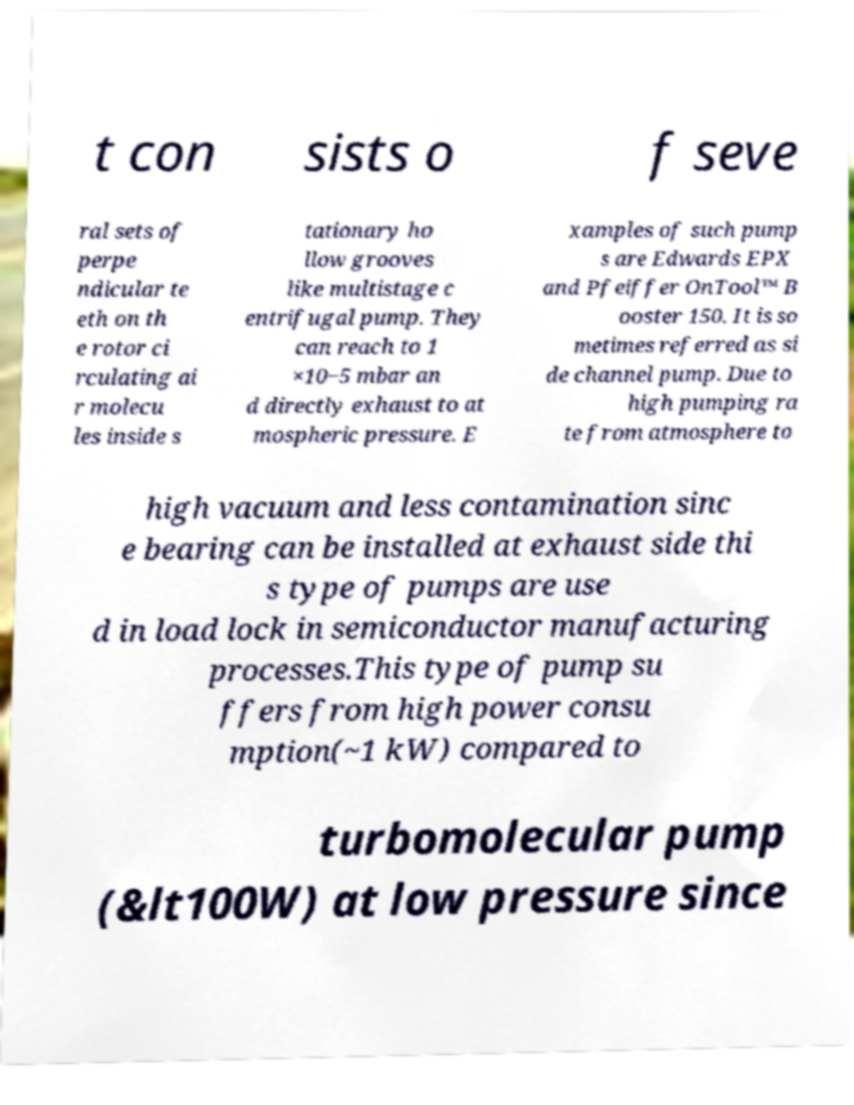I need the written content from this picture converted into text. Can you do that? t con sists o f seve ral sets of perpe ndicular te eth on th e rotor ci rculating ai r molecu les inside s tationary ho llow grooves like multistage c entrifugal pump. They can reach to 1 ×10−5 mbar an d directly exhaust to at mospheric pressure. E xamples of such pump s are Edwards EPX and Pfeiffer OnTool™ B ooster 150. It is so metimes referred as si de channel pump. Due to high pumping ra te from atmosphere to high vacuum and less contamination sinc e bearing can be installed at exhaust side thi s type of pumps are use d in load lock in semiconductor manufacturing processes.This type of pump su ffers from high power consu mption(~1 kW) compared to turbomolecular pump (&lt100W) at low pressure since 